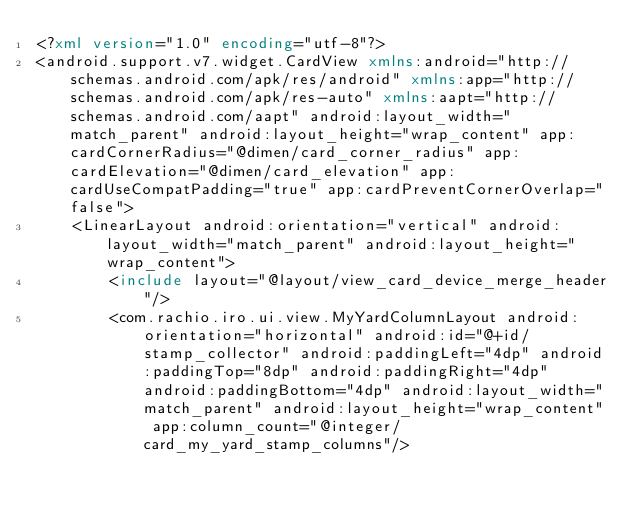<code> <loc_0><loc_0><loc_500><loc_500><_XML_><?xml version="1.0" encoding="utf-8"?>
<android.support.v7.widget.CardView xmlns:android="http://schemas.android.com/apk/res/android" xmlns:app="http://schemas.android.com/apk/res-auto" xmlns:aapt="http://schemas.android.com/aapt" android:layout_width="match_parent" android:layout_height="wrap_content" app:cardCornerRadius="@dimen/card_corner_radius" app:cardElevation="@dimen/card_elevation" app:cardUseCompatPadding="true" app:cardPreventCornerOverlap="false">
    <LinearLayout android:orientation="vertical" android:layout_width="match_parent" android:layout_height="wrap_content">
        <include layout="@layout/view_card_device_merge_header"/>
        <com.rachio.iro.ui.view.MyYardColumnLayout android:orientation="horizontal" android:id="@+id/stamp_collector" android:paddingLeft="4dp" android:paddingTop="8dp" android:paddingRight="4dp" android:paddingBottom="4dp" android:layout_width="match_parent" android:layout_height="wrap_content" app:column_count="@integer/card_my_yard_stamp_columns"/></code> 